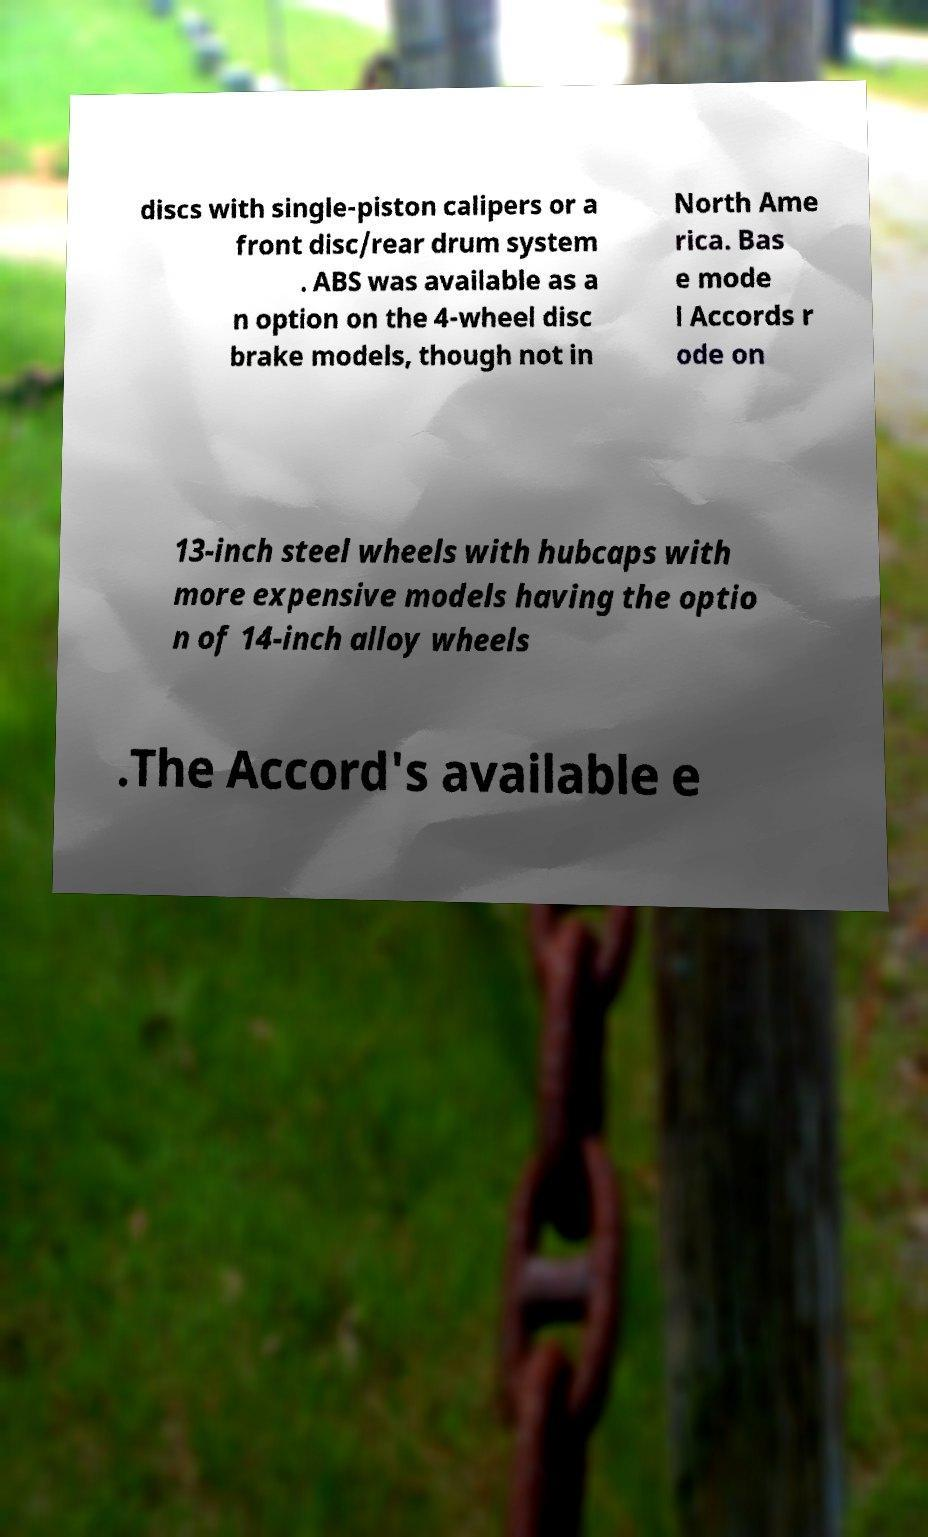There's text embedded in this image that I need extracted. Can you transcribe it verbatim? discs with single-piston calipers or a front disc/rear drum system . ABS was available as a n option on the 4-wheel disc brake models, though not in North Ame rica. Bas e mode l Accords r ode on 13-inch steel wheels with hubcaps with more expensive models having the optio n of 14-inch alloy wheels .The Accord's available e 